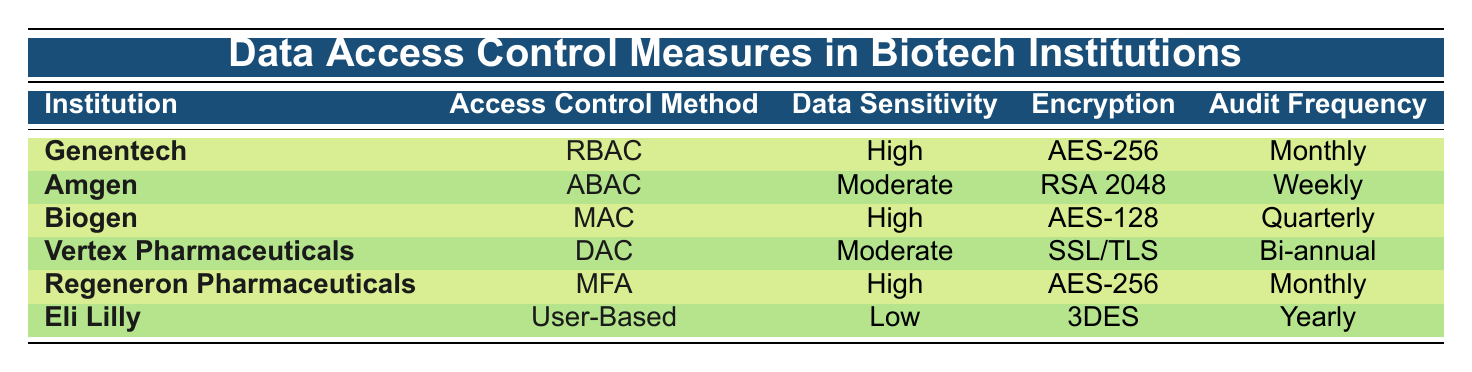What access control method does Biogen use? Biogen's access control method is listed in the table; it shows "Mandatory Access Control (MAC)" as the access control method for Biogen.
Answer: Mandatory Access Control (MAC) How often does Amgen conduct audit logs? The table indicates that Amgen has an "Audit Log Frequency" of "Weekly." Therefore, Amgen conducts audit logs every week.
Answer: Weekly Which institutions use the AES-256 encryption? By reviewing the table, both Genentech and Regeneron Pharmaceuticals are noted to utilize "AES-256" encryption for their data security measures.
Answer: Genentech, Regeneron Pharmaceuticals How many institutions have a data sensitivity level classified as High? A quick count of the rows in the table identifies three institutions with a "Data Sensitivity Level" of "High" (Genentech, Biogen, Regeneron Pharmaceuticals).
Answer: 3 Is it true that Eli Lilly uses Multi-factor Authentication for data access? The table clearly lists the access control method for Eli Lilly as "User-Based Access Control," not Multi-factor Authentication, confirming that the statement is false.
Answer: False Which access control method is used by the institution with the highest data sensitivity level? The institutions with the highest data sensitivity level (High) are Genentech and Regeneron Pharmaceuticals. Their access control methods, respectively, are "RBAC" and "MFA."
Answer: RBAC, MFA Can you identify an institution that uses a Low data sensitivity level and describe its audit log frequency? The table shows that Eli Lilly is the only institution categorized as "Low" in the "Data Sensitivity Level," and its "Audit Log Frequency" is set to "Yearly."
Answer: Yearly What is the average audit log frequency for institutions with Moderate data sensitivity? Institutions with Moderate data sensitivity level are Amgen and Vertex Pharmaceuticals. Amgen has "Weekly" and Vertex Pharmaceuticals has "Bi-annual" which is equivalent to 26 weeks. To find the average: (1 week + 26 weeks) / 2 = 13.5 weeks, which can also be stated as "Every 13.5 weeks."
Answer: Every 13.5 weeks 